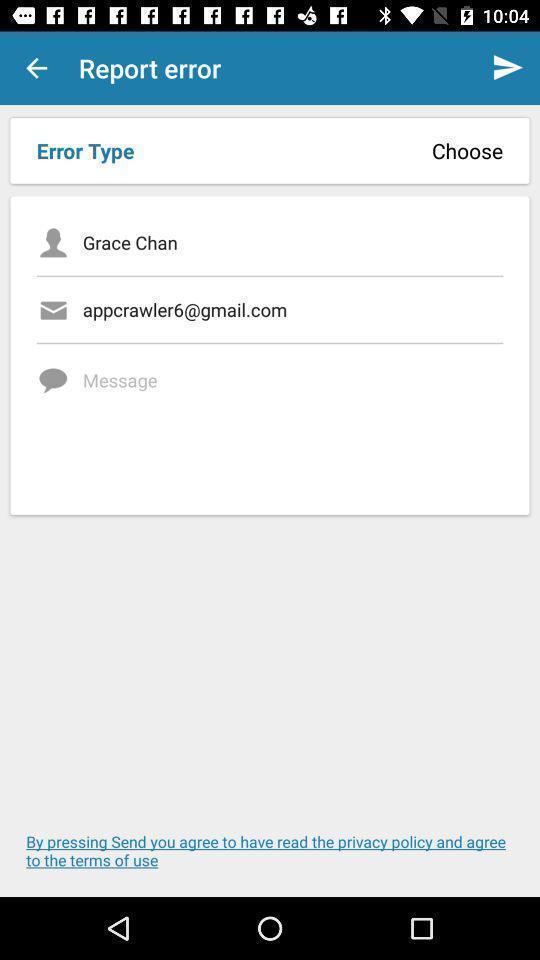Explain the elements present in this screenshot. Window displaying a page to report error. 